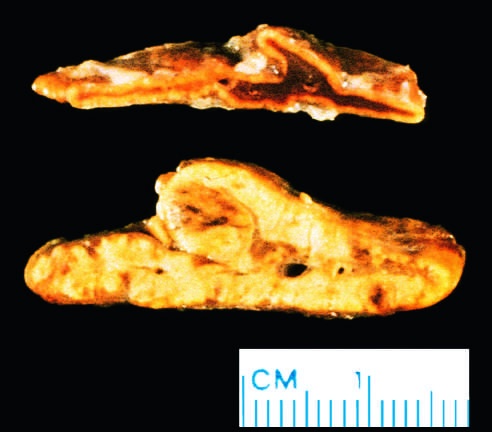s a possible precursor lesion contrasted with a normal adrenal gland?
Answer the question using a single word or phrase. No 